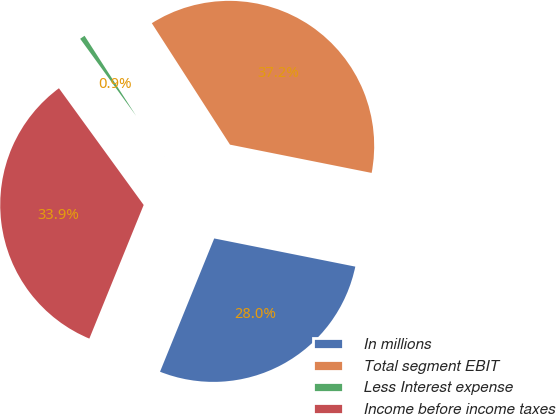Convert chart to OTSL. <chart><loc_0><loc_0><loc_500><loc_500><pie_chart><fcel>In millions<fcel>Total segment EBIT<fcel>Less Interest expense<fcel>Income before income taxes<nl><fcel>28.01%<fcel>37.24%<fcel>0.89%<fcel>33.86%<nl></chart> 